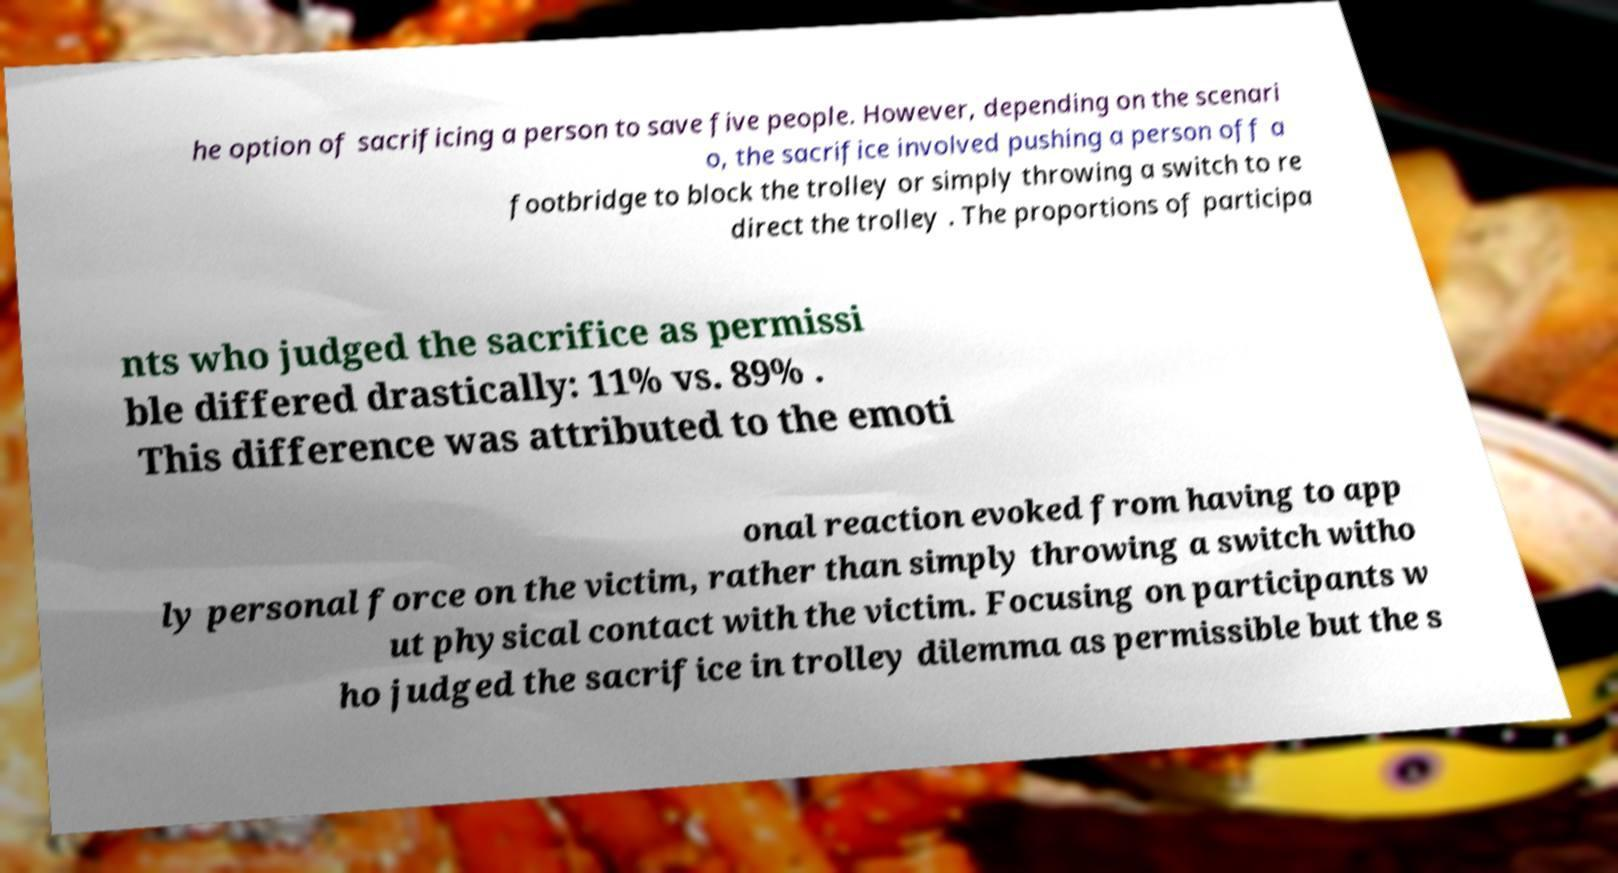What messages or text are displayed in this image? I need them in a readable, typed format. he option of sacrificing a person to save five people. However, depending on the scenari o, the sacrifice involved pushing a person off a footbridge to block the trolley or simply throwing a switch to re direct the trolley . The proportions of participa nts who judged the sacrifice as permissi ble differed drastically: 11% vs. 89% . This difference was attributed to the emoti onal reaction evoked from having to app ly personal force on the victim, rather than simply throwing a switch witho ut physical contact with the victim. Focusing on participants w ho judged the sacrifice in trolley dilemma as permissible but the s 